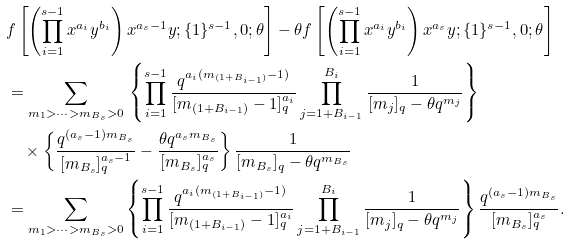<formula> <loc_0><loc_0><loc_500><loc_500>& f \left [ \left ( \prod _ { i = 1 } ^ { s - 1 } x ^ { a _ { i } } y ^ { b _ { i } } \right ) x ^ { a _ { s } - 1 } y ; \{ 1 \} ^ { s - 1 } , 0 ; \theta \right ] - \theta f \left [ \left ( \prod _ { i = 1 } ^ { s - 1 } x ^ { a _ { i } } y ^ { b _ { i } } \right ) x ^ { a _ { s } } y ; \{ 1 \} ^ { s - 1 } , 0 ; \theta \right ] \\ & = \sum _ { m _ { 1 } > \cdots > m _ { B _ { s } } > 0 } \, \left \{ \prod _ { i = 1 } ^ { s - 1 } \frac { q ^ { a _ { i } ( m _ { ( 1 + B _ { i - 1 } ) } - 1 ) } } { [ m _ { ( 1 + B _ { i - 1 } ) } - 1 ] _ { q } ^ { a _ { i } } } \prod _ { j = 1 + B _ { i - 1 } } ^ { B _ { i } } \frac { 1 } { [ m _ { j } ] _ { q } - \theta q ^ { m _ { j } } } \right \} \\ & \quad \times \left \{ \frac { q ^ { ( a _ { s } - 1 ) m _ { B _ { s } } } } { [ m _ { B _ { s } } ] _ { q } ^ { a _ { s } - 1 } } - \frac { \theta q ^ { a _ { s } m _ { B _ { s } } } } { [ m _ { B _ { s } } ] _ { q } ^ { a _ { s } } } \right \} \frac { 1 } { [ m _ { B _ { s } } ] _ { q } - \theta q ^ { m _ { B _ { s } } } } \\ & = \sum _ { m _ { 1 } > \cdots > m _ { B _ { s } } > 0 } \left \{ \prod _ { i = 1 } ^ { s - 1 } \frac { q ^ { a _ { i } ( m _ { ( 1 + B _ { i - 1 } ) } - 1 ) } } { [ m _ { ( 1 + B _ { i - 1 } ) } - 1 ] _ { q } ^ { a _ { i } } } \prod _ { j = 1 + B _ { i - 1 } } ^ { B _ { i } } \frac { 1 } { [ m _ { j } ] _ { q } - \theta q ^ { m _ { j } } } \right \} \frac { q ^ { ( a _ { s } - 1 ) m _ { B _ { s } } } } { [ m _ { B _ { s } } ] _ { q } ^ { a _ { s } } } .</formula> 